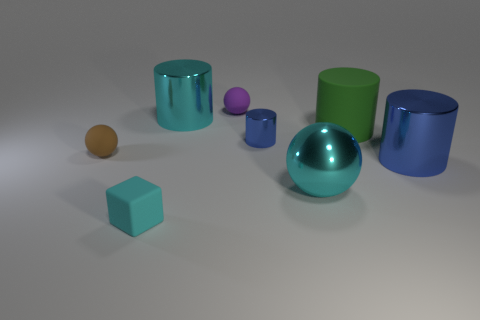Describe the positioning of the shiny blue sphere in relation to the other objects. The shiny blue sphere is centrally positioned in the image, slightly to the foreground. It rests alone without being in direct contact with the other items, thereby creating a visual focal point amidst the collection of objects. 